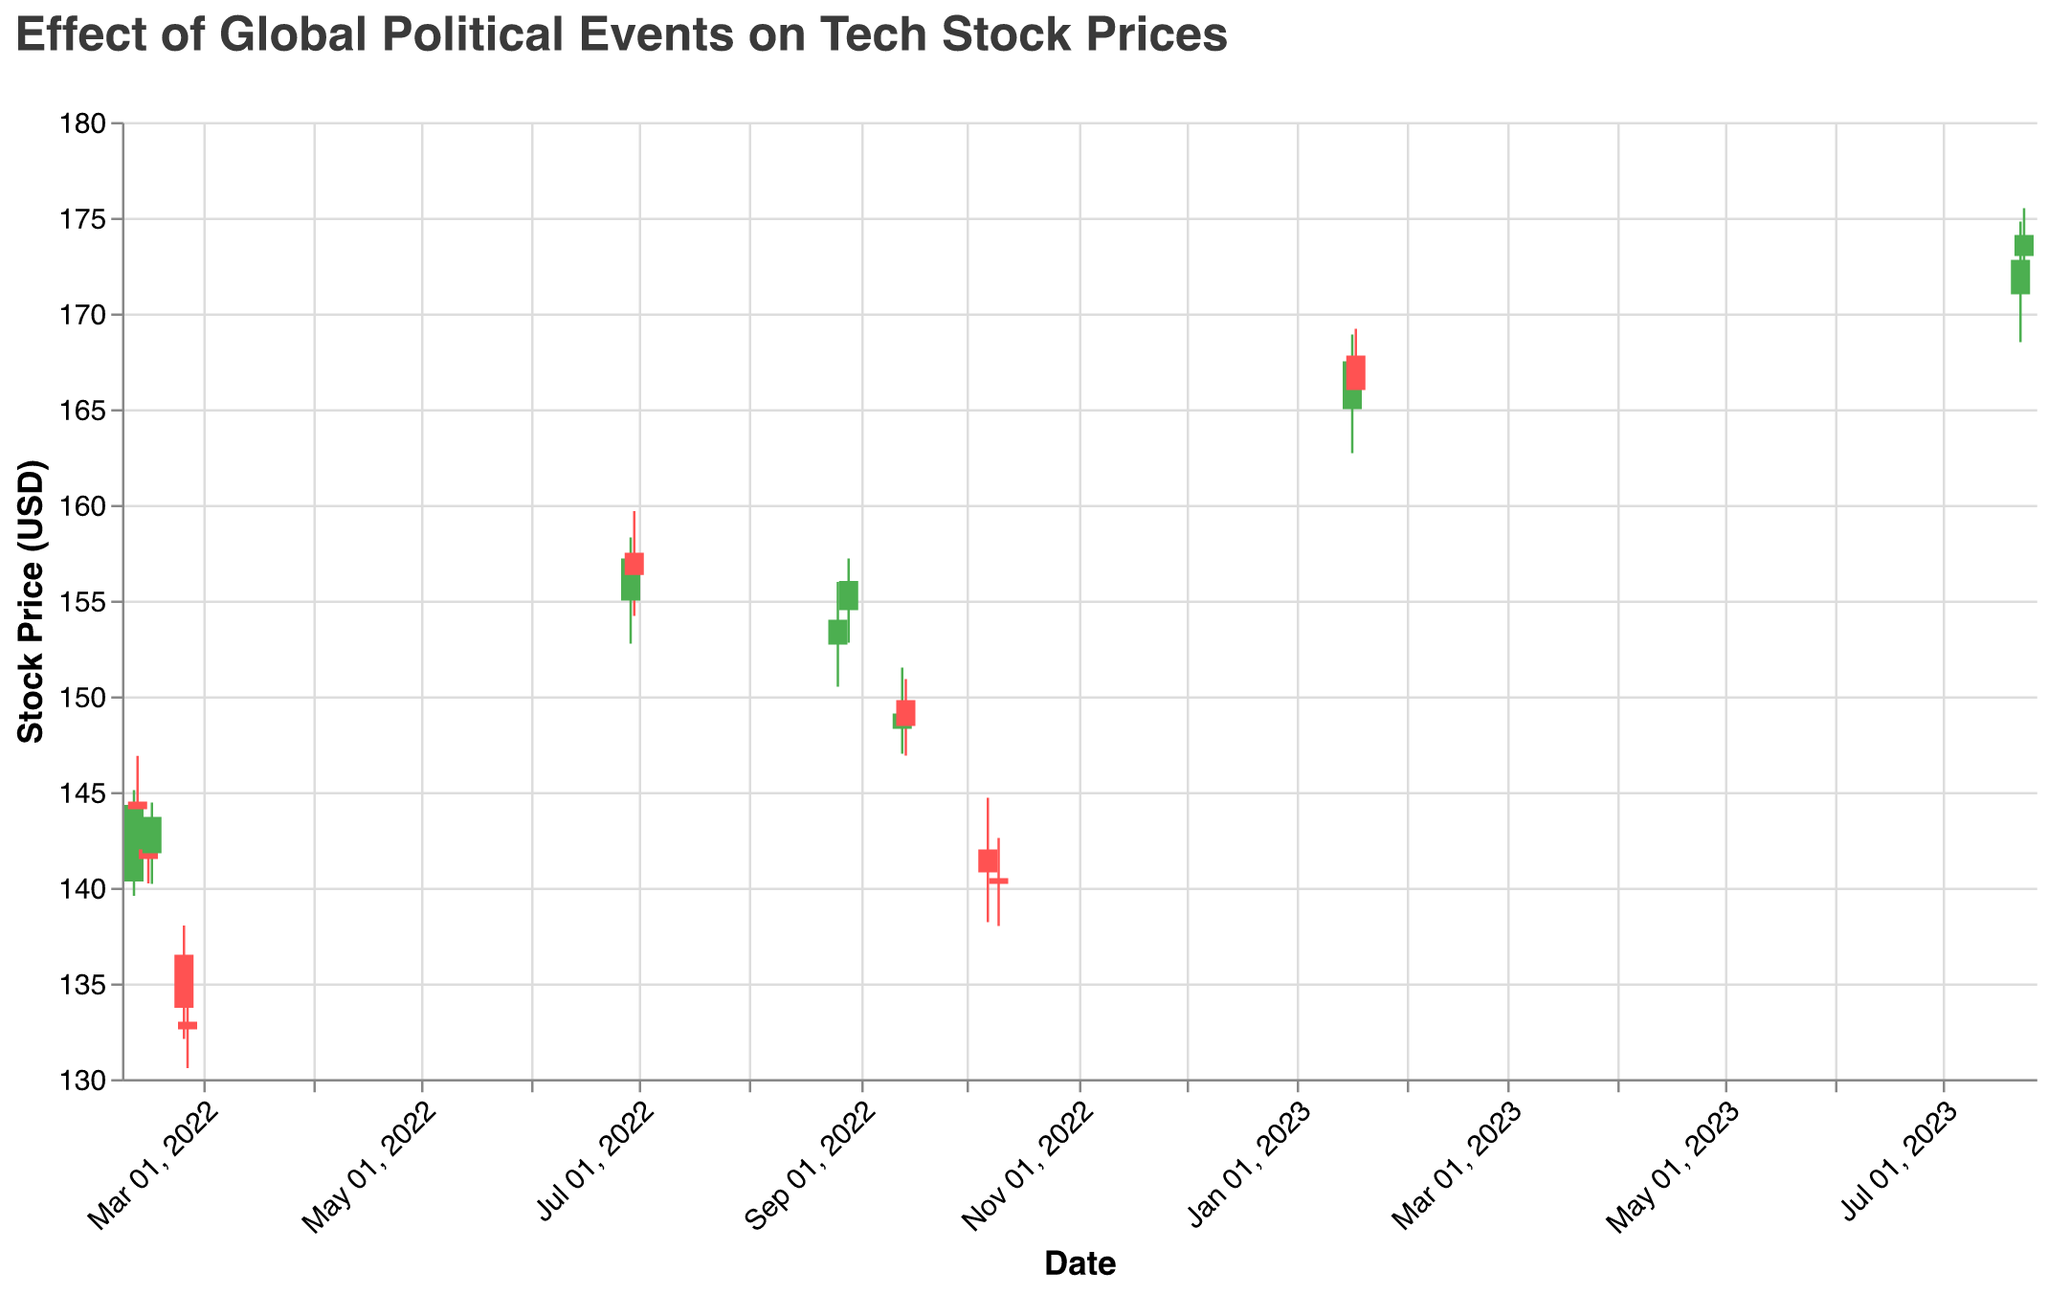What is the title of the plot? The title is located at the top of the plot and typically summarizes the main subject of the data visualization. Here, it shows "Effect of Global Political Events on Tech Stock Prices".
Answer: Effect of Global Political Events on Tech Stock Prices During which event did the stock price experience the lowest close? Look for the lowest "Close" value in the chart and identify the corresponding event listed in the "Event" field. The lowest close is 132.60 during the "Russian Invasion of Ukraine".
Answer: Russian Invasion of Ukraine How many candlesticks show an increase in stock price? Count the number of candlesticks that are colored green, indicating the "Open" value is less than the "Close" value. Visual inspection reveals green candlesticks for 10 days.
Answer: 10 Which event had the highest trading volume? Check the "Volume" value for each event. The highest trading volume is 42356000 during the "Russian Invasion of Ukraine" on February 25, 2022.
Answer: Russian Invasion of Ukraine What is the average closing price during the NATO Summit? Identify the "Close" values on the dates of the NATO Summit and compute the average. The closing prices are 157.20 and 156.34, so the average is (157.20 + 156.34) / 2 = 156.77
Answer: 156.77 Compare the stock price change during the "US Inflation Report" versus the "EU Energy Crisis". Which period saw a greater negative change? Calculate the difference between "Close" and "Open" for each date within the periods. US Inflation Report saw changes of -0.65 (148.45 - 149.10) and -1.35 (149.10 - 148.30). EU Energy Crisis saw changes of -1.80 (140.20 - 142.00) and -1.00 (140.80 - 140.50). Summing these changes gives -2.00 for US Inflation Report and -2.80 for EU Energy Crisis.
Answer: EU Energy Crisis Which event marked the highest closing stock price? Identify the event associated with the highest "Close" value. The highest closing stock price is 174.10 during the "US Tech Policy Changes" on July 24, 2023.
Answer: US Tech Policy Changes How did the stock price behave during the "Russia-Ukraine Tensions"? Review the "Close" values during the dates of the "Russia-Ukraine Tensions" to observe the trend. The closing prices increased from 144.32 to 144.10, then dropped to 141.50, and finally rose to 143.70.
Answer: Varied with initial increase, drop, and recovery What was the stock price trend during the "US-China Trade War Escalation"? Note the "Close" values for the dates associated with the event to identify the trend. The stock price closed at 154.00 on August 26, 2022, and rose to 156.03 on August 29, 2022, indicating an upward trend.
Answer: Upward trend Did the Davos World Economic Forum result in a higher or lower stock price by the end of the event? Compare the "Close" value at the beginning and end of the event. On January 17, 2023, the stock price closed at 167.50, and on January 18, 2023, it closed at 166.00, indicating a drop.
Answer: Lower 